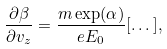<formula> <loc_0><loc_0><loc_500><loc_500>\frac { \partial \beta } { \partial v _ { z } } = \frac { m \exp ( \alpha ) } { e E _ { 0 } } [ \dots ] ,</formula> 